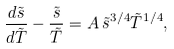Convert formula to latex. <formula><loc_0><loc_0><loc_500><loc_500>\frac { d \tilde { s } } { d \tilde { T } } - \frac { \tilde { s } } { \tilde { T } } = A \, \tilde { s } ^ { 3 / 4 } \tilde { T } ^ { 1 / 4 } ,</formula> 